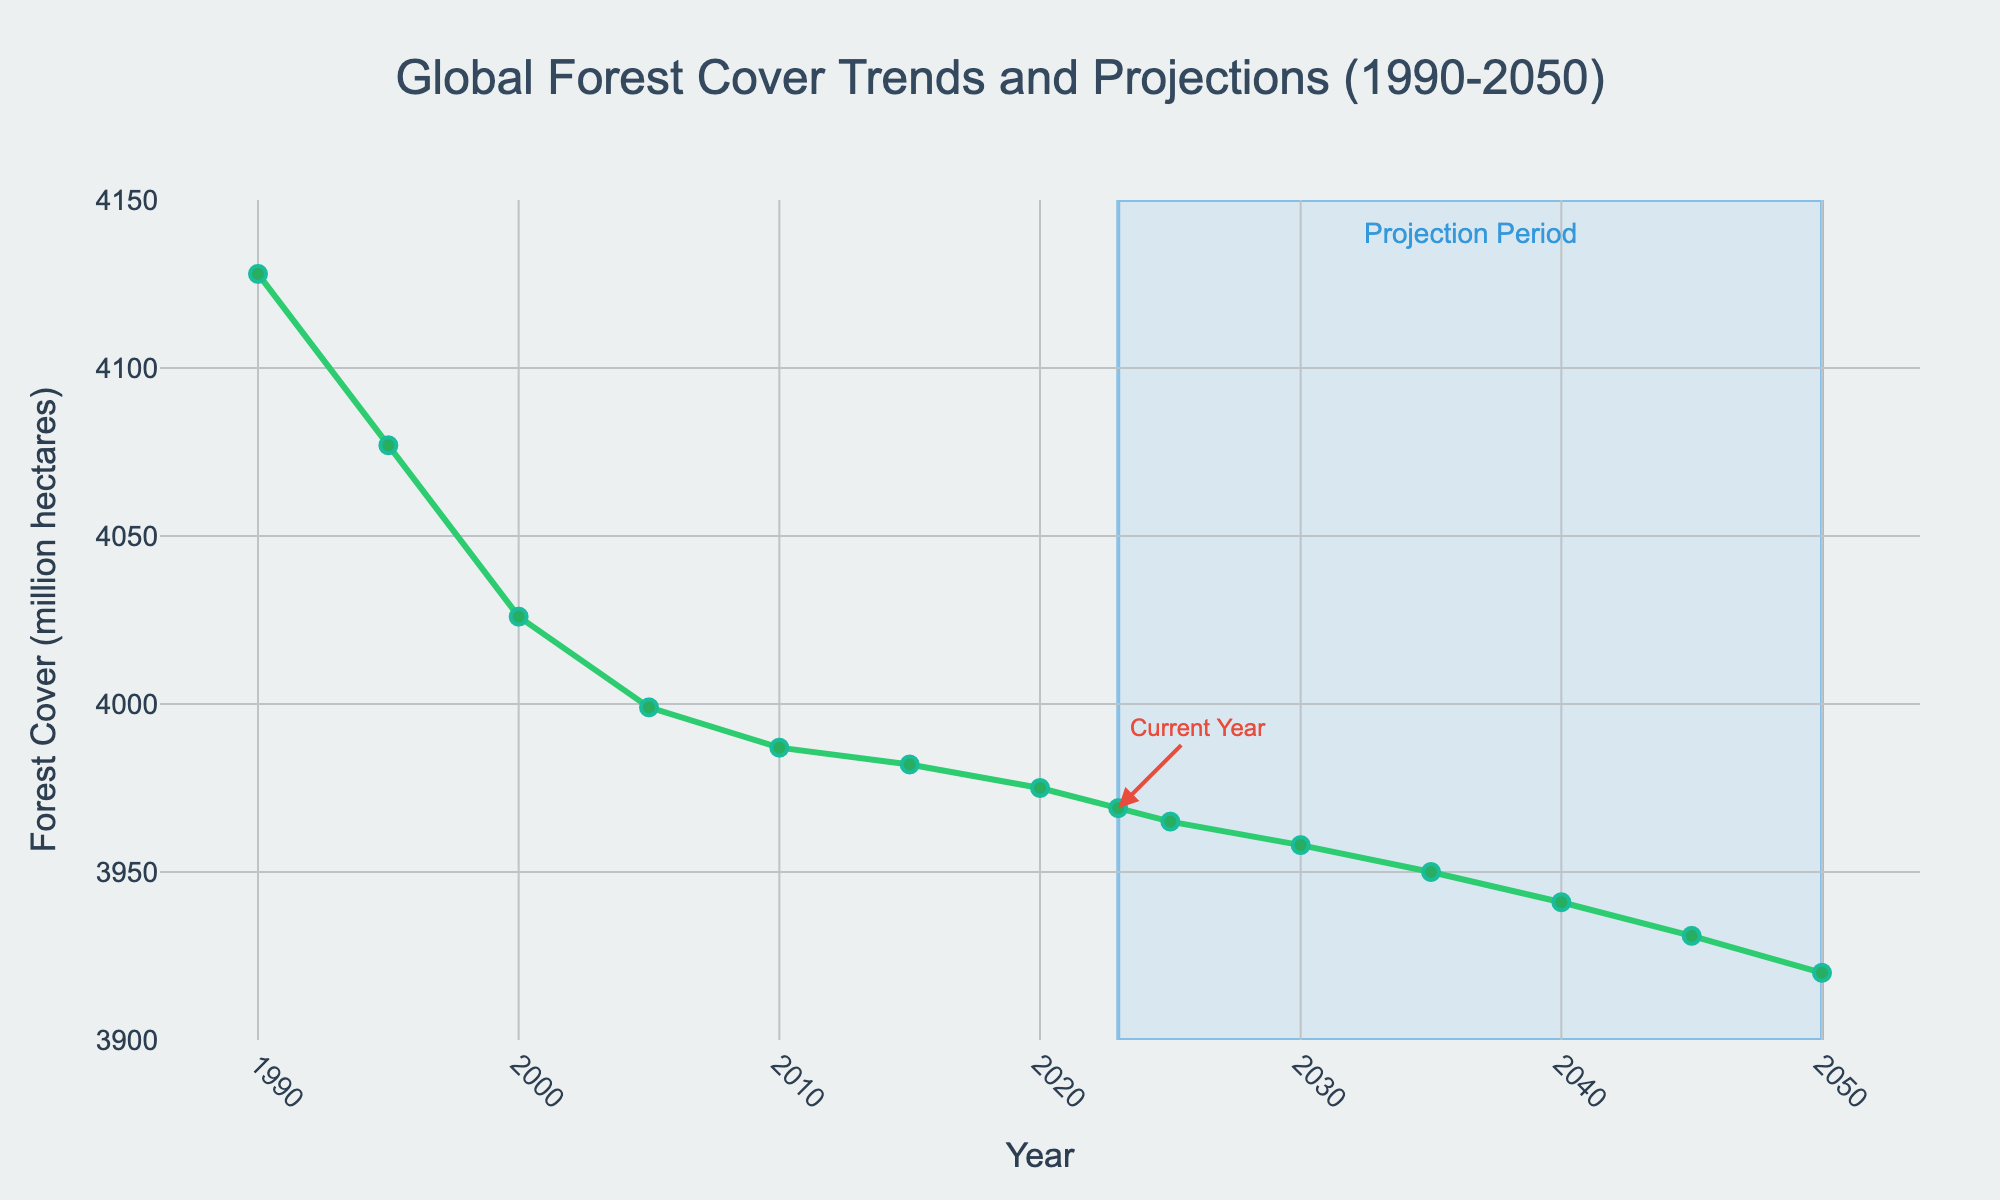What is the global forest cover in the year 2020? Look at the data point for the year 2020 on the x-axis and see the corresponding value on the y-axis. It shows 3975 million hectares.
Answer: 3975 million hectares How much did the global forest cover decrease between 1990 and 2023? Subtract the 2023 forest cover (3969 million hectares) from the 1990 forest cover (4128 million hectares). 4128 - 3969 = 159 million hectares.
Answer: 159 million hectares What is the expected global forest cover in 2050 based on current trends? Check the value on the y-axis corresponding to the year 2050 on the x-axis. It shows 3920 million hectares.
Answer: 3920 million hectares During which period is the decline in forest cover highlighted with a specific color, and what color is it? The decline from 2023 to 2050 is highlighted with a light blue color.
Answer: Light blue By how much is the forest cover projected to decrease from 2023 to 2050? Subtract the 2050 projection (3920 million hectares) from the 2023 value (3969 million hectares). 3969 - 3920 = 49 million hectares.
Answer: 49 million hectares What is the average global forest cover for the years 1990, 2000, and 2010? Add the forest cover values for 1990 (4128 million hectares), 2000 (4026 million hectares), and 2010 (3987 million hectares), then divide by 3. (4128 + 4026 + 3987) / 3 = 4047 million hectares.
Answer: 4047 million hectares Between which two consecutive years is the forest cover reduction the smallest? Compare the reductions between each pair of consecutive years: 1990-1995, 1995-2000, 2000-2005, 2005-2010, 2010-2015, 2015-2020, 2020-2023. The reduction from 2010 to 2015 is the smallest (3987 - 3982 = 5 million hectares).
Answer: 2010-2015 What is the median value of global forest cover for the given years from 1990 to 2023? List all the values (4128, 4077, 4026, 3999, 3987, 3982, 3975, 3969), then find the middle value(s). The median is the average of 3999 and 3987, which is (3999 + 3987) / 2 = 3993 million hectares.
Answer: 3993 million hectares 